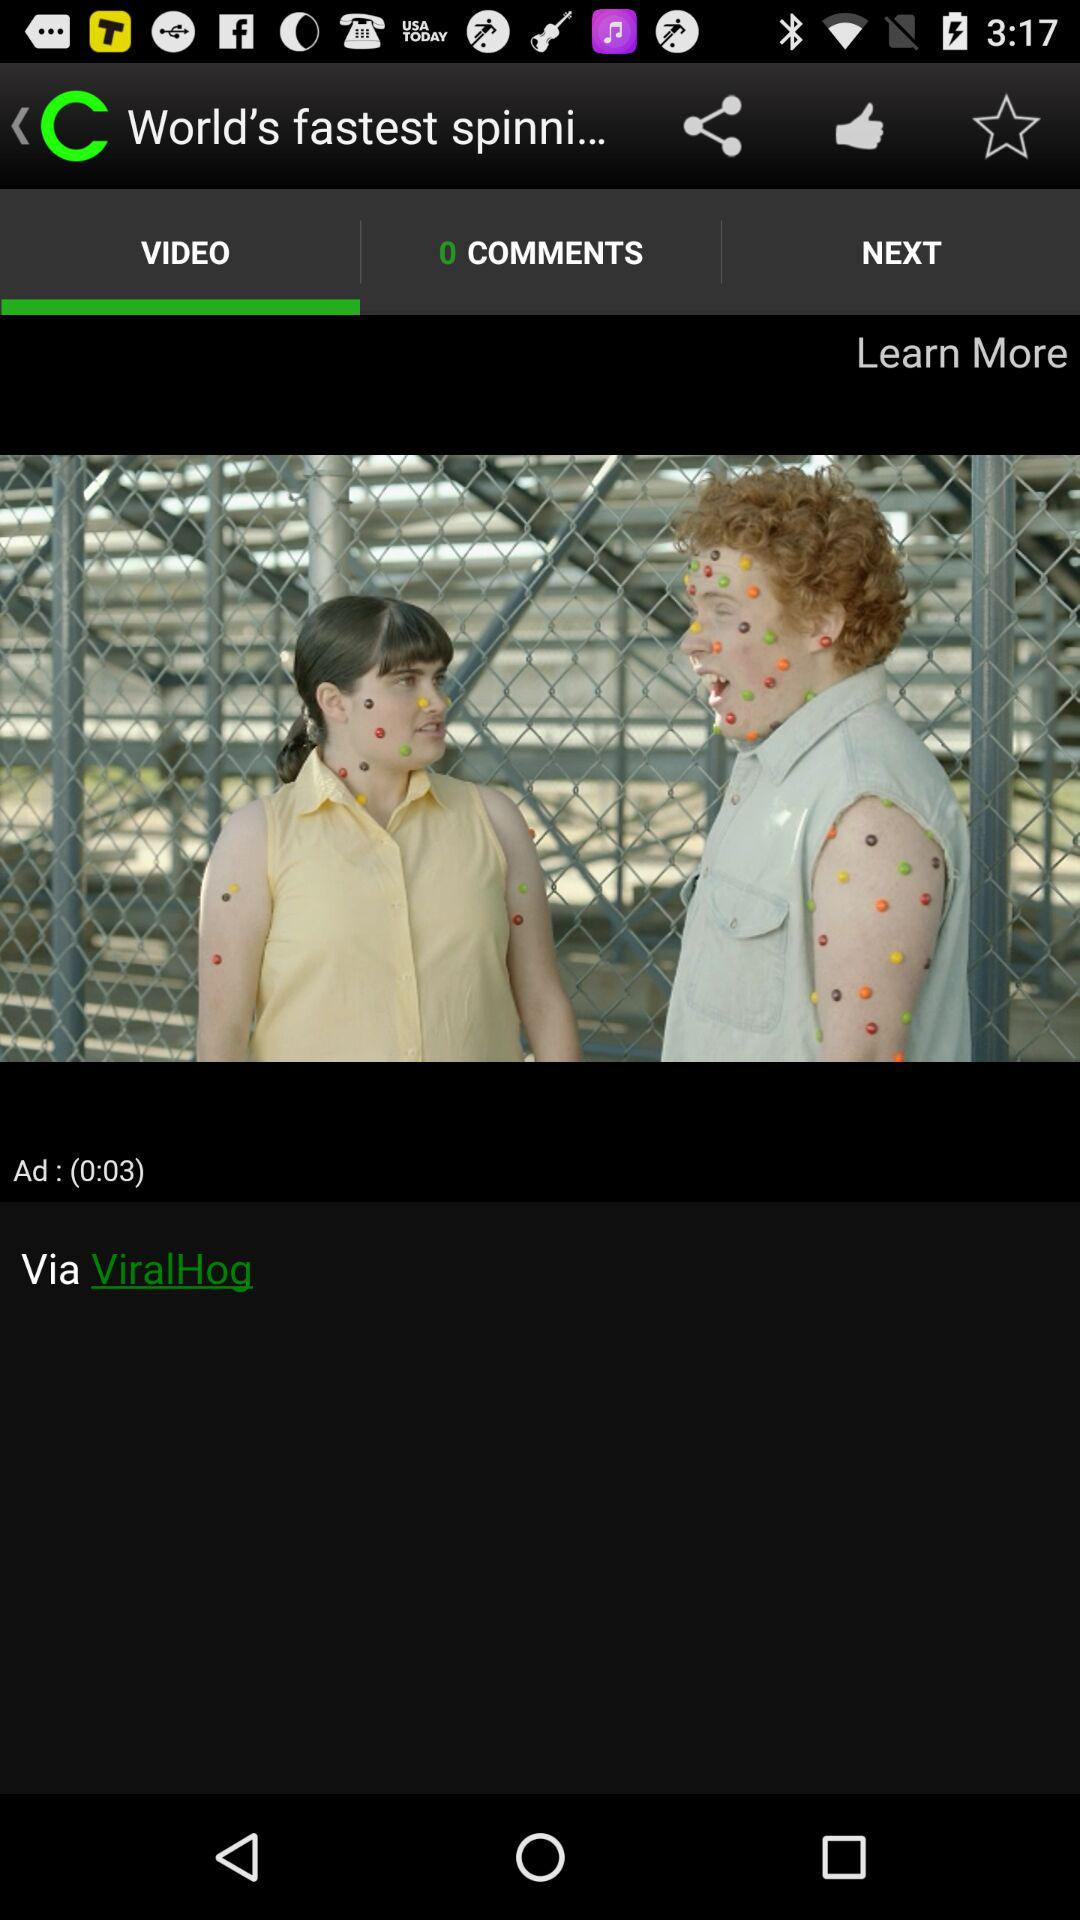How many comments are there? There are 0 comments. 